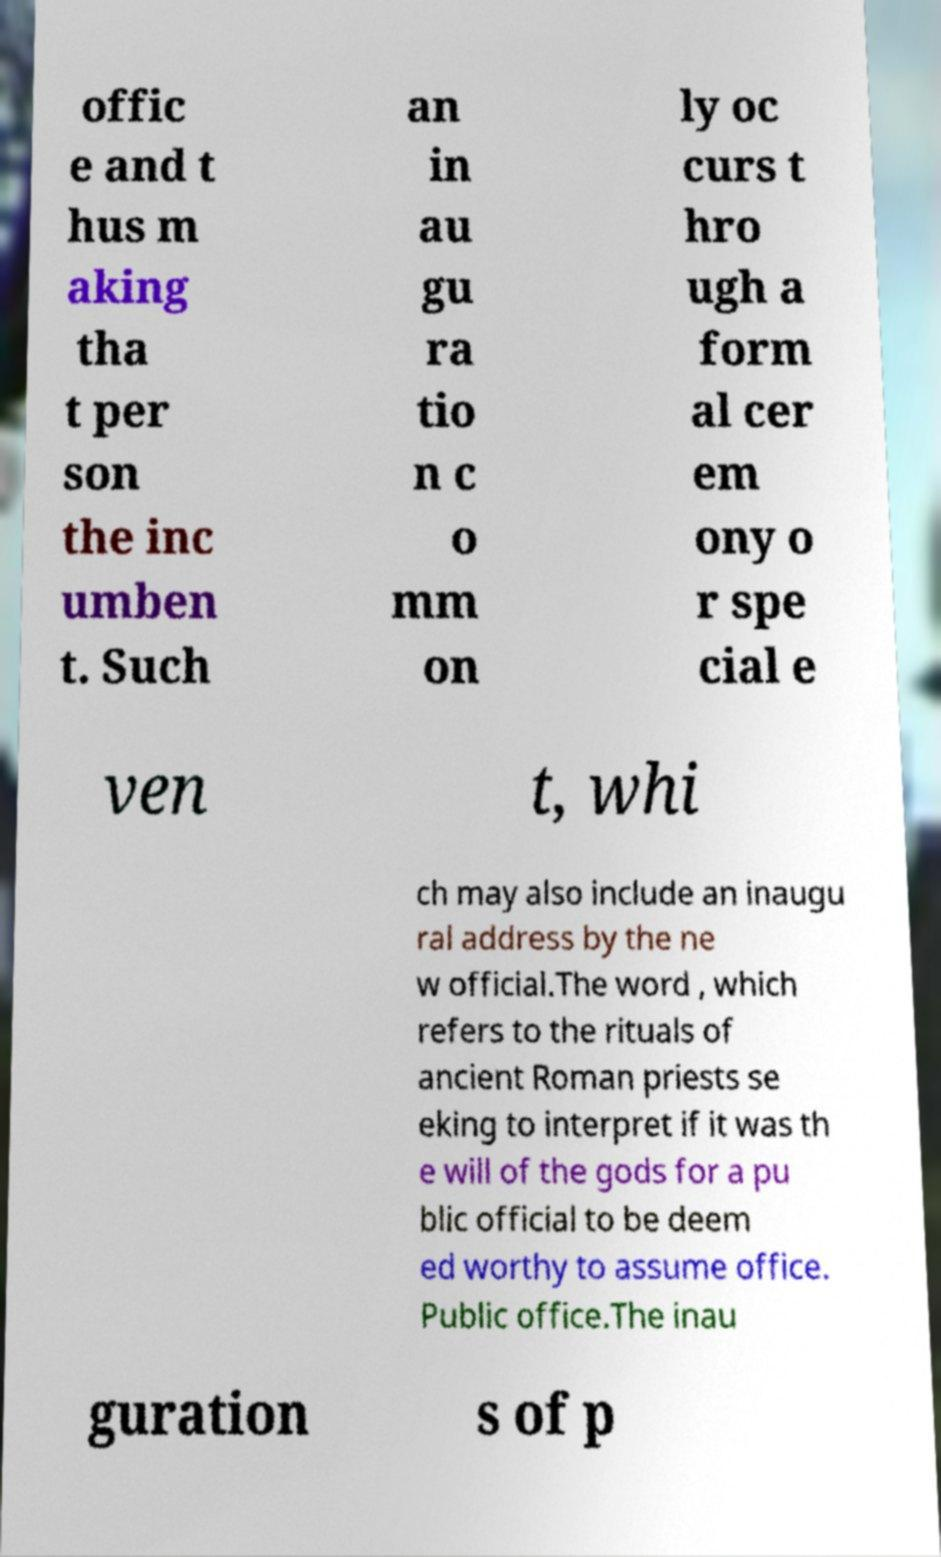Please read and relay the text visible in this image. What does it say? offic e and t hus m aking tha t per son the inc umben t. Such an in au gu ra tio n c o mm on ly oc curs t hro ugh a form al cer em ony o r spe cial e ven t, whi ch may also include an inaugu ral address by the ne w official.The word , which refers to the rituals of ancient Roman priests se eking to interpret if it was th e will of the gods for a pu blic official to be deem ed worthy to assume office. Public office.The inau guration s of p 